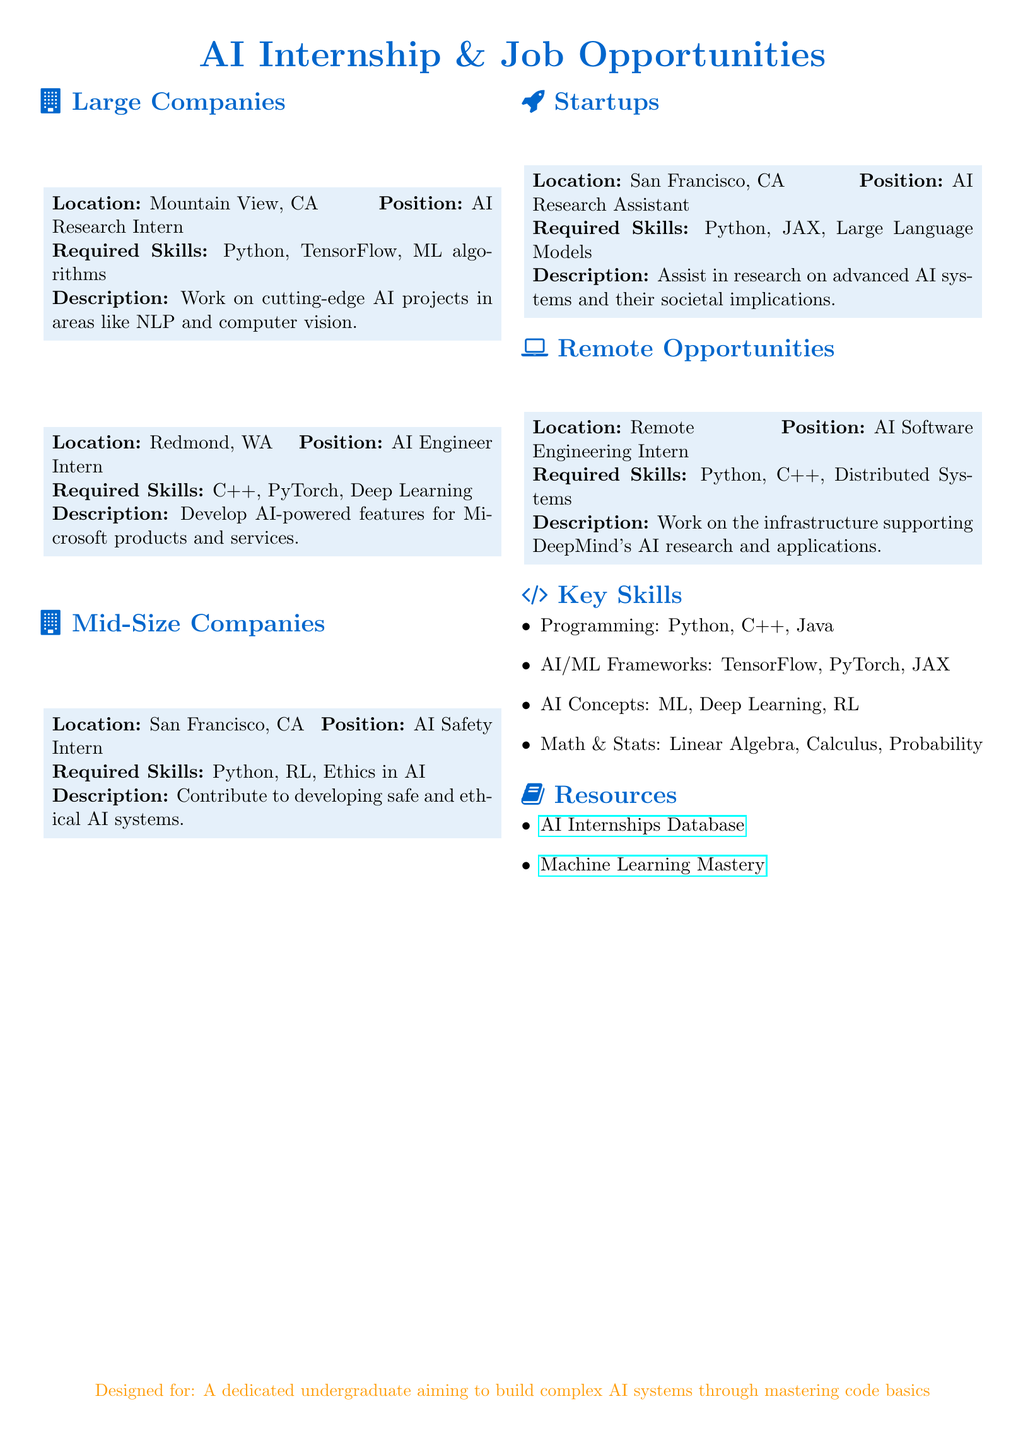What company is offering an AI Research Intern position? The document lists Google as offering an AI Research Intern position.
Answer: Google Where is the AI Safety Intern position located? The AI Safety Intern position is located in San Francisco, CA as indicated in the document.
Answer: San Francisco, CA Which programming language is required for the AI Software Engineering Intern position? The document specifies Python as a required programming language for the AI Software Engineering Intern position.
Answer: Python What are two skills required for the AI Research Assistant role? The document lists Python and JAX as required skills for the AI Research Assistant role at Anthropic.
Answer: Python, JAX How many remote opportunities are mentioned in the document? The document highlights one remote opportunity for the AI Software Engineering Intern position.
Answer: One Which section lists key skills for AI roles? The key skills for AI roles are listed in the "Key Skills" section.
Answer: Key Skills What is the main focus of the internship at OpenAI? The document indicates that the main focus of the internship at OpenAI is on developing safe and ethical AI systems.
Answer: Safe and ethical AI systems Which company is located in Mountain View, CA? The document states that Google is located in Mountain View, CA.
Answer: Google What is the title of the document? The title of the document is AI Internship & Job Opportunities.
Answer: AI Internship & Job Opportunities 